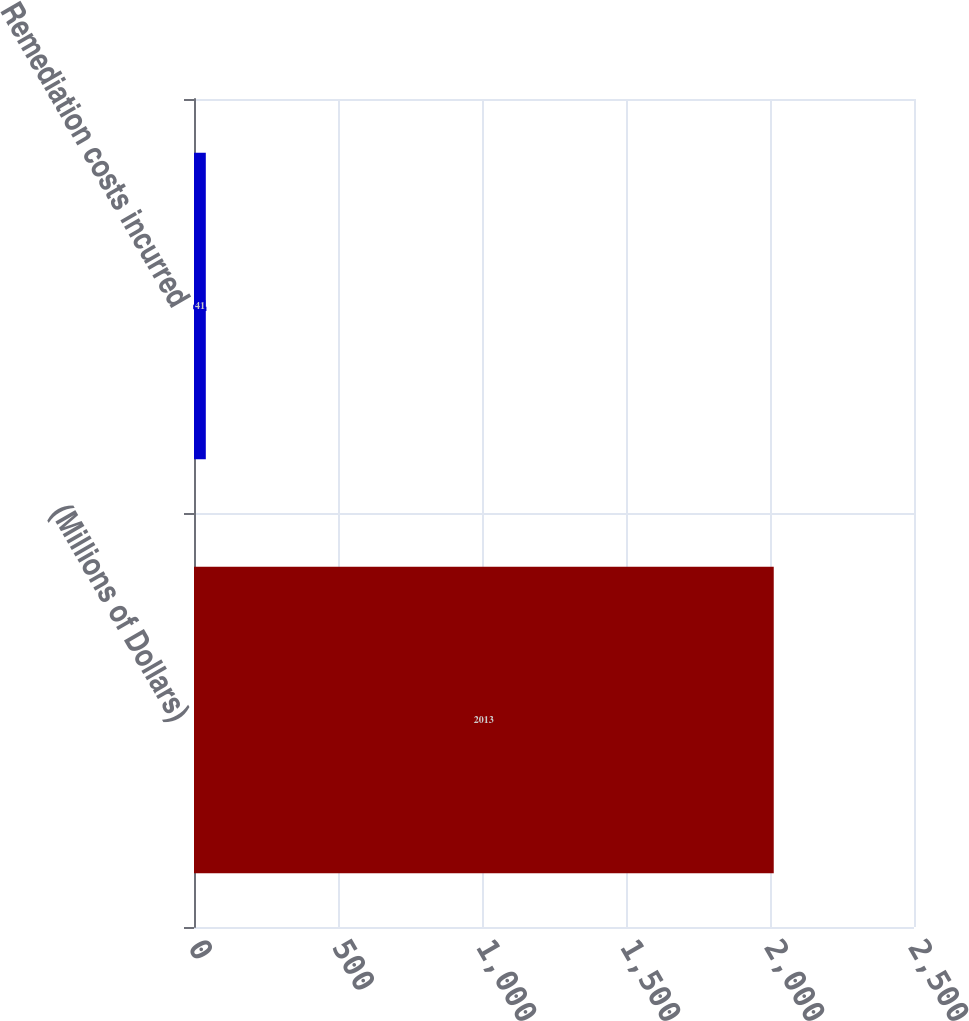Convert chart to OTSL. <chart><loc_0><loc_0><loc_500><loc_500><bar_chart><fcel>(Millions of Dollars)<fcel>Remediation costs incurred<nl><fcel>2013<fcel>41<nl></chart> 